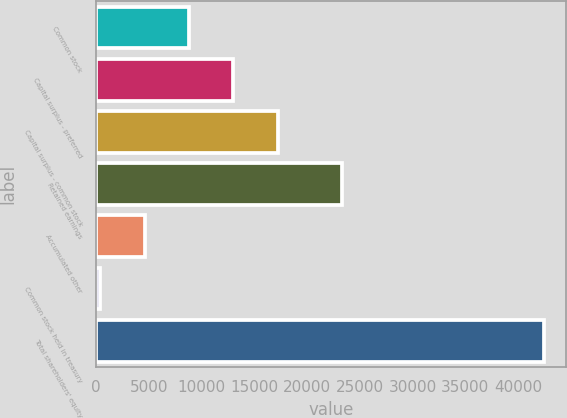Convert chart to OTSL. <chart><loc_0><loc_0><loc_500><loc_500><bar_chart><fcel>Common stock<fcel>Capital surplus - preferred<fcel>Capital surplus - common stock<fcel>Retained earnings<fcel>Accumulated other<fcel>Common stock held in treasury<fcel>Total shareholders' equity<nl><fcel>8808<fcel>13008<fcel>17208<fcel>23325<fcel>4608<fcel>408<fcel>42408<nl></chart> 